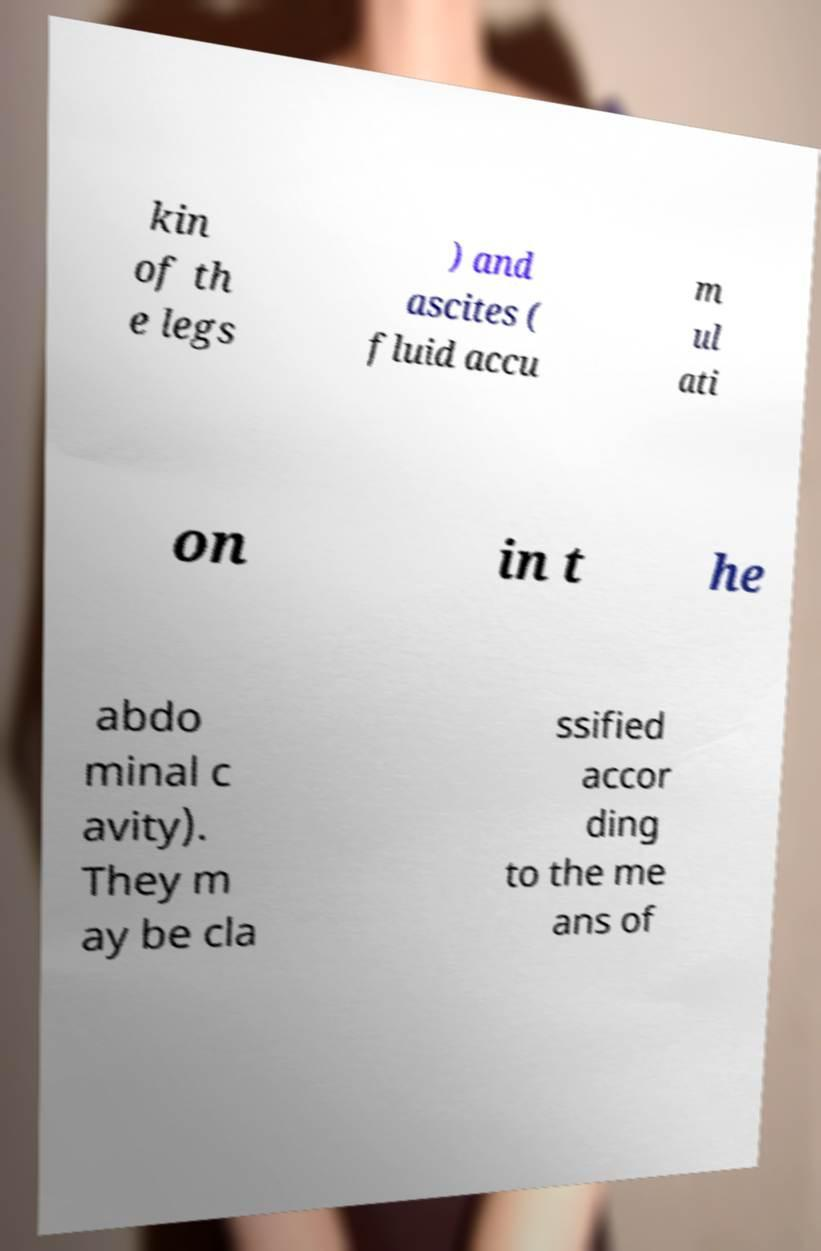What messages or text are displayed in this image? I need them in a readable, typed format. kin of th e legs ) and ascites ( fluid accu m ul ati on in t he abdo minal c avity). They m ay be cla ssified accor ding to the me ans of 